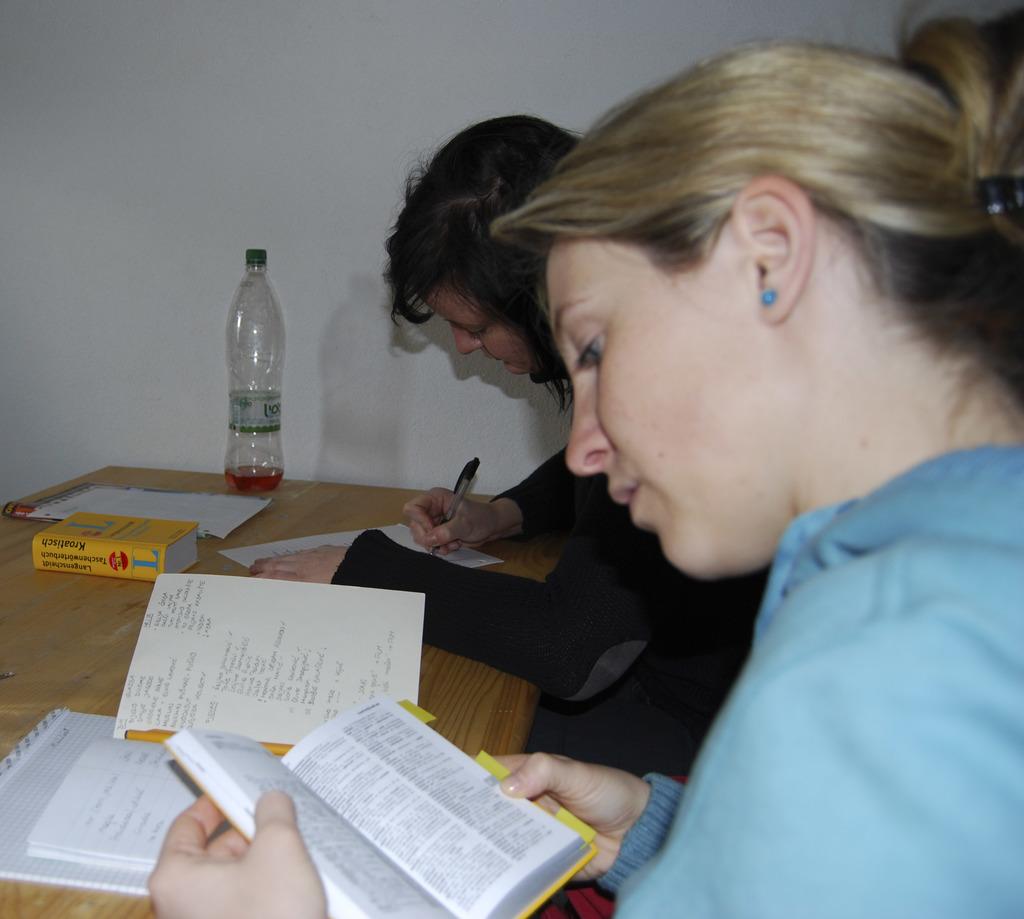What is the bold blue letter on the yellow book?
Your answer should be very brief. L. 